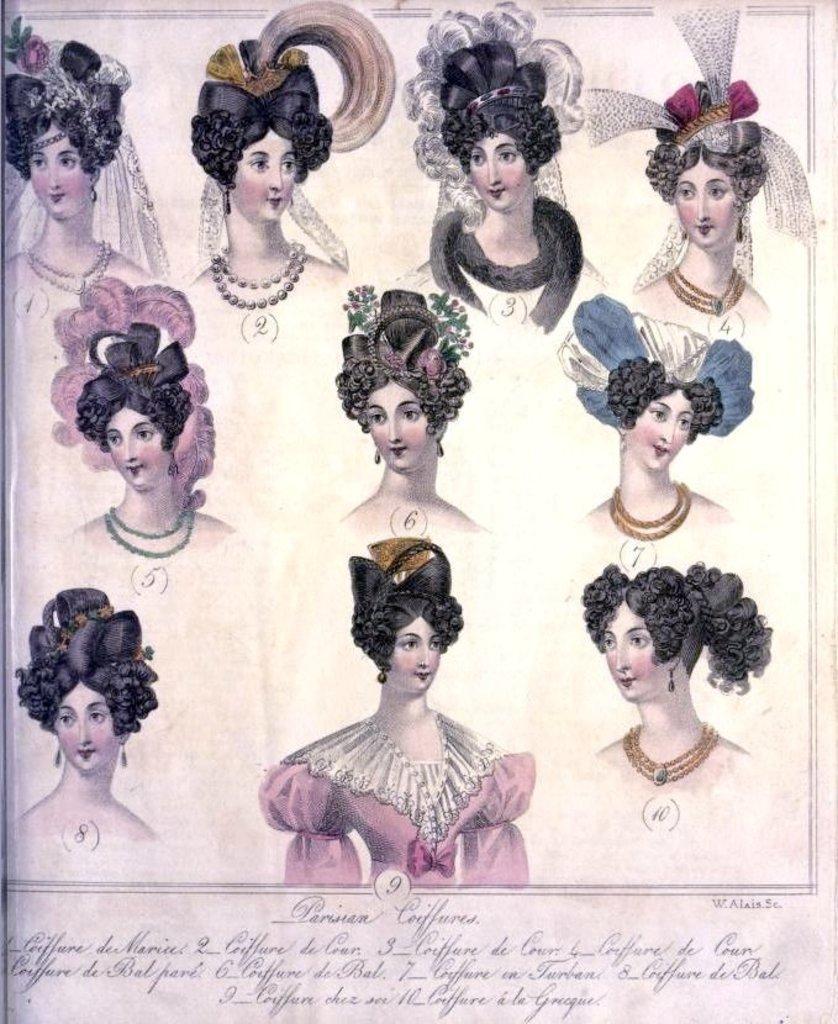Can you describe this image briefly? In this image I can see the sketch of woman wearing different head wear on a paper. I can see something is written to the bottom of the image. 